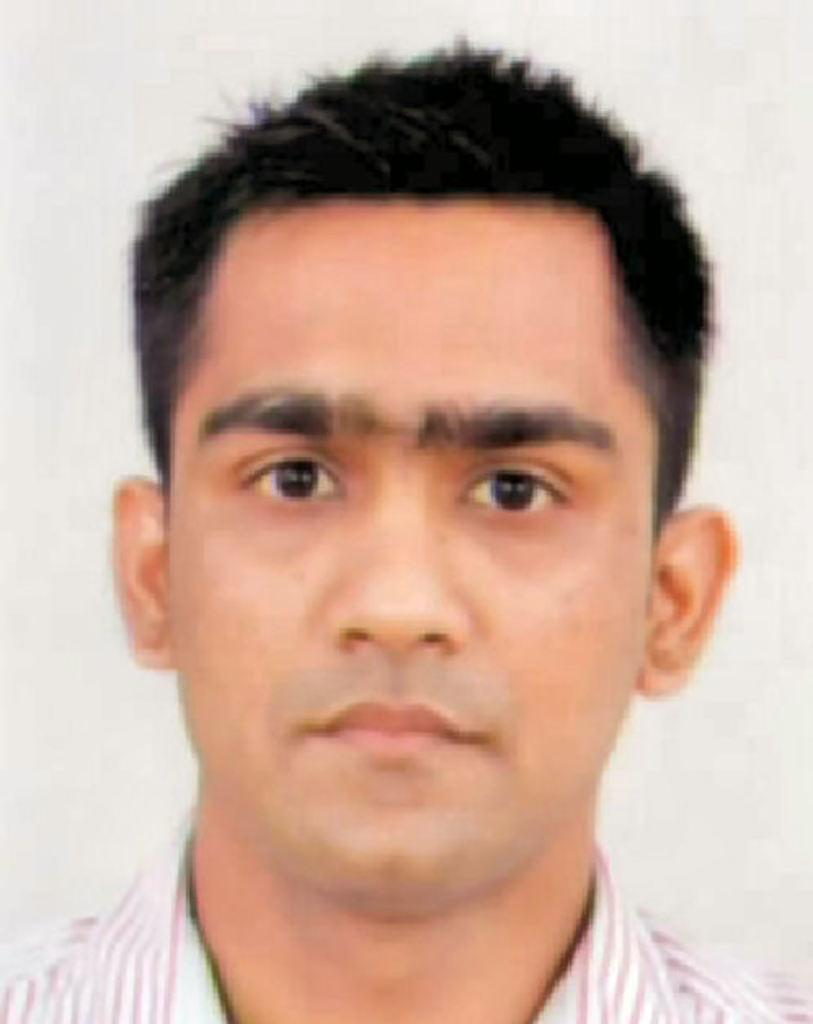What is the main subject of the image? There is a photo of a person in the image. What type of advertisement is displayed on the spade in the image? There is no spade or advertisement present in the image; it only features a photo of a person. 